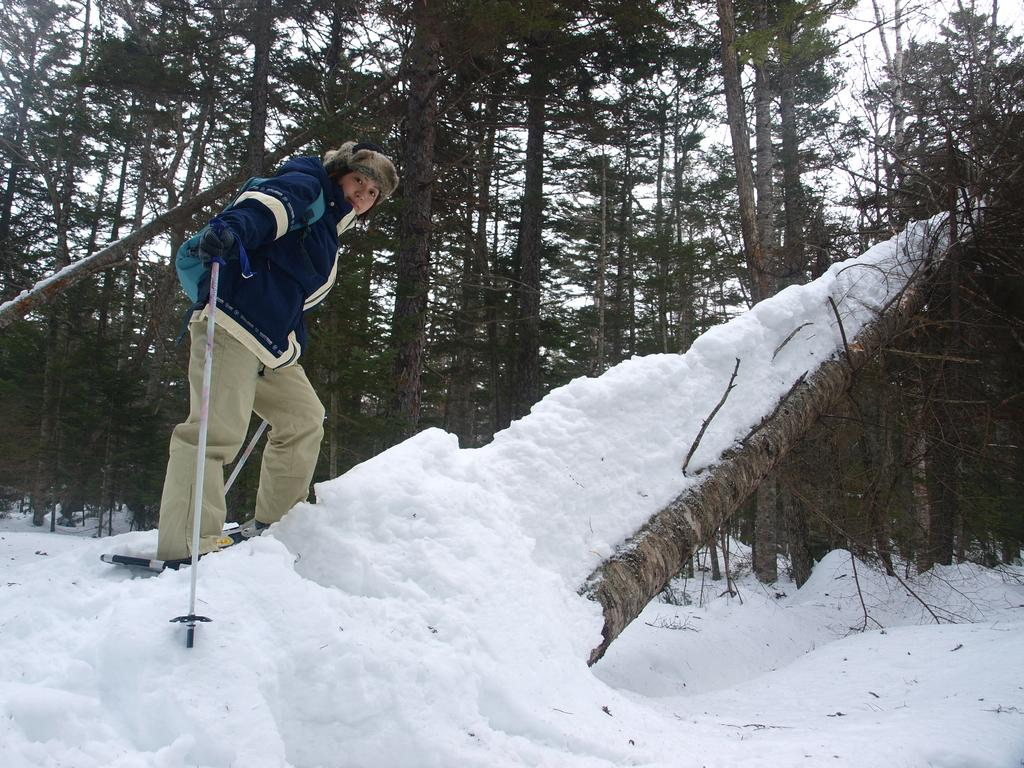What can be seen in the image? There is a person in the image. What is the person wearing on their head? The person is wearing a cap. What is the person wearing on their hands? The person is wearing gloves. What is the person holding in their hand? The person is holding a stick in their hand. What is the weather like in the image? There is snow in the image, indicating a cold or wintery environment. What can be seen in the background of the image? There are trees in the background of the image. What type of curtain can be seen in the image? There are no curtains present in the image. 